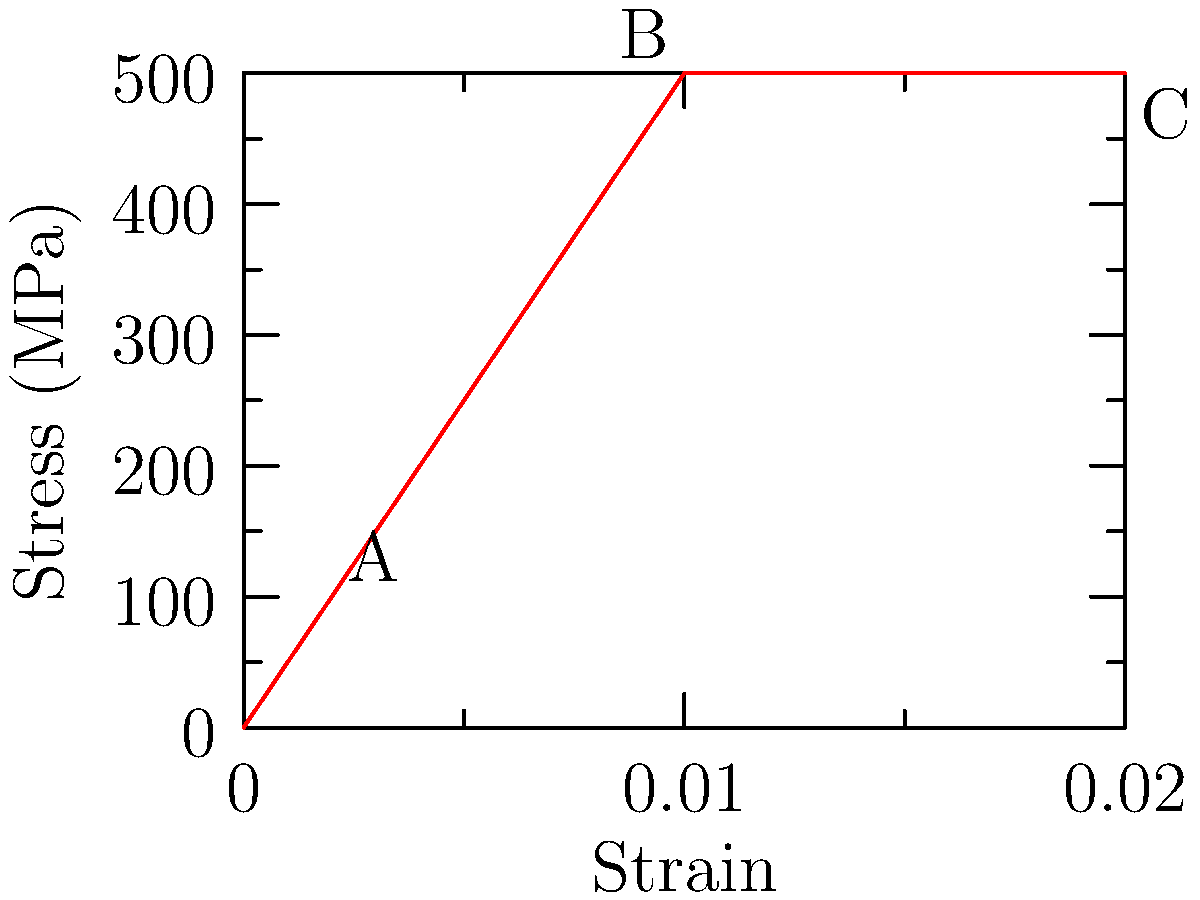In the stress-strain curve shown above for a hypothetical material, what does the region between points B and C represent, and how does it relate to the material's behavior under tensile loading? To understand the stress-strain curve and the region between points B and C, let's analyze the graph step-by-step:

1. The curve represents the relationship between stress (vertical axis) and strain (horizontal axis) for a material under tensile loading.

2. Point A represents the elastic limit or yield point of the material.

3. The region from the origin to point A is the elastic region, where the material follows Hooke's law ($$\sigma = E\epsilon$$, where $$\sigma$$ is stress, $$E$$ is Young's modulus, and $$\epsilon$$ is strain).

4. From point A to B, the material undergoes plastic deformation, where permanent changes in shape occur.

5. The region between points B and C is a horizontal line, indicating that stress remains constant while strain increases.

6. This horizontal region represents plastic flow or perfect plasticity, where the material continues to deform without an increase in stress.

7. In this region, the material experiences necking, where a localized reduction in cross-sectional area occurs.

8. The constant stress in this region is known as the ultimate tensile strength (UTS) of the material.

9. After point C, in a real material, the stress would typically decrease as the cross-sectional area continues to reduce until fracture occurs.

The region between B and C is crucial for understanding the material's ductility and its behavior under large strains, which is important for predicting its performance in applications involving significant plastic deformation.
Answer: Plastic flow region; constant stress with increasing strain due to necking 